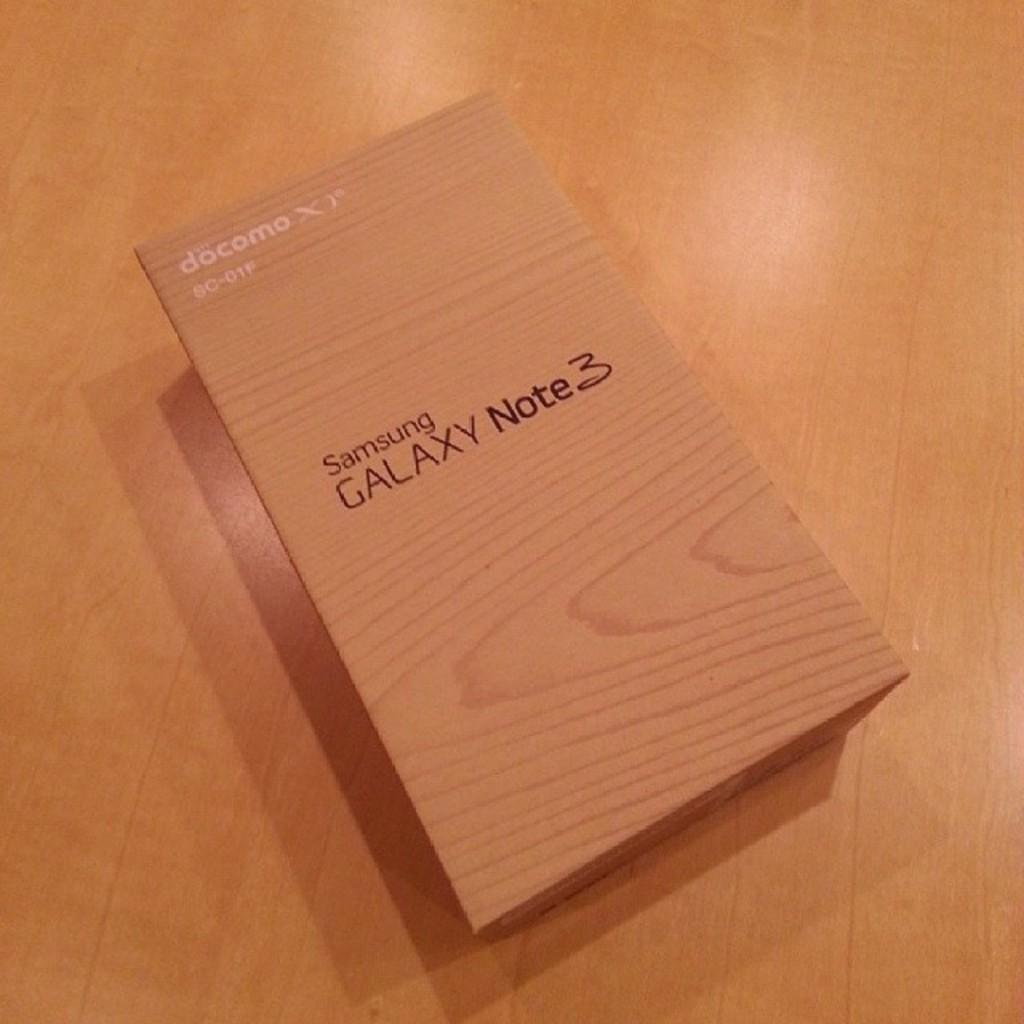Provide a one-sentence caption for the provided image. A wooden box for a Samsung Galaxy Note 3. 